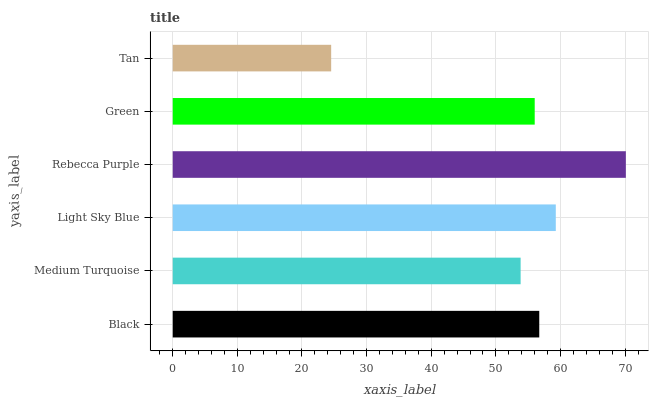Is Tan the minimum?
Answer yes or no. Yes. Is Rebecca Purple the maximum?
Answer yes or no. Yes. Is Medium Turquoise the minimum?
Answer yes or no. No. Is Medium Turquoise the maximum?
Answer yes or no. No. Is Black greater than Medium Turquoise?
Answer yes or no. Yes. Is Medium Turquoise less than Black?
Answer yes or no. Yes. Is Medium Turquoise greater than Black?
Answer yes or no. No. Is Black less than Medium Turquoise?
Answer yes or no. No. Is Black the high median?
Answer yes or no. Yes. Is Green the low median?
Answer yes or no. Yes. Is Light Sky Blue the high median?
Answer yes or no. No. Is Light Sky Blue the low median?
Answer yes or no. No. 